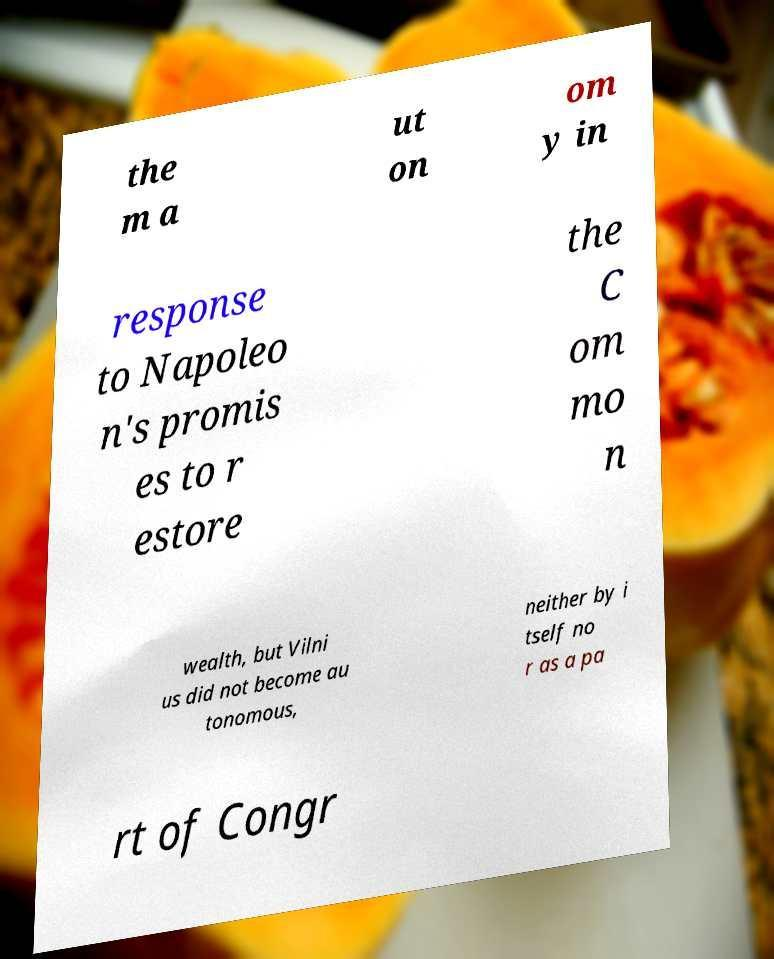What messages or text are displayed in this image? I need them in a readable, typed format. the m a ut on om y in response to Napoleo n's promis es to r estore the C om mo n wealth, but Vilni us did not become au tonomous, neither by i tself no r as a pa rt of Congr 